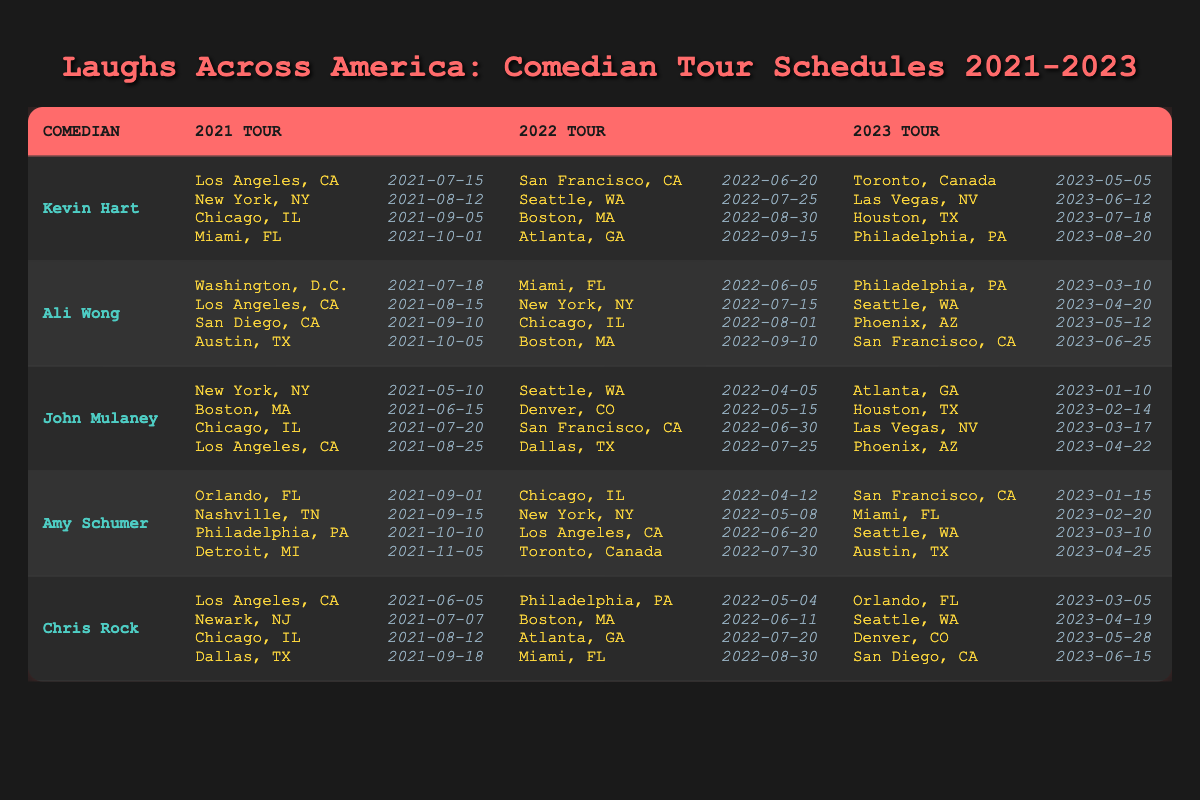What locations did Kevin Hart perform in during 2022? The table shows that in 2022, Kevin Hart performed in San Francisco, CA; Seattle, WA; Boston, MA; and Atlanta, GA.
Answer: San Francisco, CA; Seattle, WA; Boston, MA; Atlanta, GA Which comedian performed in New York, NY in 2021? By examining the table, we can see that both Kevin Hart and John Mulaney performed in New York, NY in 2021.
Answer: Kevin Hart; John Mulaney How many different locations did Ali Wong visit during her 2023 tour? The table indicates that Ali Wong performed in four locations in 2023: Philadelphia, PA; Seattle, WA; Phoenix, AZ; and San Francisco, CA. Count these four locations for the answer.
Answer: 4 Did Chris Rock perform in Orlando, FL in 2021? Referring to the table, Chris Rock's 2021 tour included performances in Los Angeles, CA; Newark, NJ; Chicago, IL; and Dallas, TX, but Orlando, FL is not listed.
Answer: No Which comedian had their first performance of 2022 in Seattle, WA? Looking at the 2022 tour schedule in the table, John Mulaney had his first performance in Seattle, WA on April 5, 2022.
Answer: John Mulaney What is the total number of performances Kevin Hart gave from 2021 to 2023? Kevin Hart had 4 performances in 2021, 4 in 2022, and 4 in 2023. This results in a total of 4 + 4 + 4 = 12 performances.
Answer: 12 Which comedian performed in the most locations during their 2022 tour? According to the table, both Ali Wong and Kevin Hart performed in 4 locations during their 2022 tour, as did John Mulaney. Hence, they all have the same number of locations.
Answer: Ali Wong; Kevin Hart; John Mulaney What were the last two cities where Amy Schumer performed in 2022? The table lists Amy Schumer's performances for 2022 as Chicago, IL; New York, NY; Los Angeles, CA; and Toronto, Canada. The last two cities are Los Angeles, CA and Toronto, Canada.
Answer: Los Angeles, CA; Toronto, Canada In which year did Chris Rock perform in Philadelphia, PA? The table indicates Chris Rock performed in Philadelphia, PA during both the 2022 tour and the 2023 tour.
Answer: 2022; 2023 What is the common performance location for both John Mulaney and Kevin Hart's 2021 tours? By checking the table, we find that neither comedian performed in the same location during 2021; they have different cities listed with no overlaps.
Answer: None 